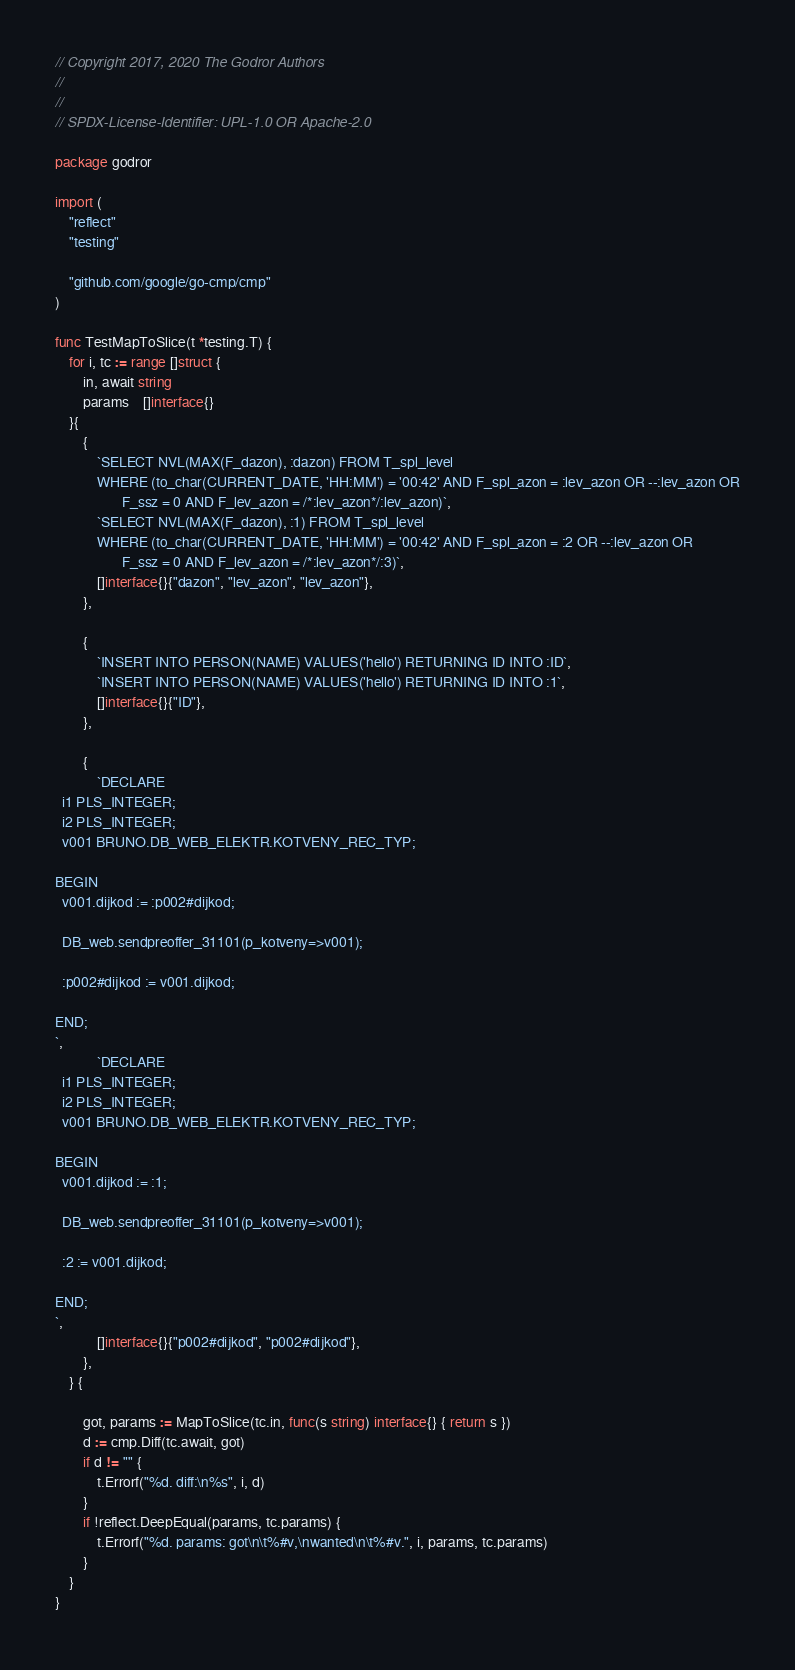<code> <loc_0><loc_0><loc_500><loc_500><_Go_>// Copyright 2017, 2020 The Godror Authors
//
//
// SPDX-License-Identifier: UPL-1.0 OR Apache-2.0

package godror

import (
	"reflect"
	"testing"

	"github.com/google/go-cmp/cmp"
)

func TestMapToSlice(t *testing.T) {
	for i, tc := range []struct {
		in, await string
		params    []interface{}
	}{
		{
			`SELECT NVL(MAX(F_dazon), :dazon) FROM T_spl_level
			WHERE (to_char(CURRENT_DATE, 'HH:MM') = '00:42' AND F_spl_azon = :lev_azon OR --:lev_azon OR
			       F_ssz = 0 AND F_lev_azon = /*:lev_azon*/:lev_azon)`,
			`SELECT NVL(MAX(F_dazon), :1) FROM T_spl_level
			WHERE (to_char(CURRENT_DATE, 'HH:MM') = '00:42' AND F_spl_azon = :2 OR --:lev_azon OR
			       F_ssz = 0 AND F_lev_azon = /*:lev_azon*/:3)`,
			[]interface{}{"dazon", "lev_azon", "lev_azon"},
		},

		{
			`INSERT INTO PERSON(NAME) VALUES('hello') RETURNING ID INTO :ID`,
			`INSERT INTO PERSON(NAME) VALUES('hello') RETURNING ID INTO :1`,
			[]interface{}{"ID"},
		},

		{
			`DECLARE
  i1 PLS_INTEGER;
  i2 PLS_INTEGER;
  v001 BRUNO.DB_WEB_ELEKTR.KOTVENY_REC_TYP;

BEGIN
  v001.dijkod := :p002#dijkod;

  DB_web.sendpreoffer_31101(p_kotveny=>v001);

  :p002#dijkod := v001.dijkod;

END;
`,
			`DECLARE
  i1 PLS_INTEGER;
  i2 PLS_INTEGER;
  v001 BRUNO.DB_WEB_ELEKTR.KOTVENY_REC_TYP;

BEGIN
  v001.dijkod := :1;

  DB_web.sendpreoffer_31101(p_kotveny=>v001);

  :2 := v001.dijkod;

END;
`,
			[]interface{}{"p002#dijkod", "p002#dijkod"},
		},
	} {

		got, params := MapToSlice(tc.in, func(s string) interface{} { return s })
		d := cmp.Diff(tc.await, got)
		if d != "" {
			t.Errorf("%d. diff:\n%s", i, d)
		}
		if !reflect.DeepEqual(params, tc.params) {
			t.Errorf("%d. params: got\n\t%#v,\nwanted\n\t%#v.", i, params, tc.params)
		}
	}
}
</code> 